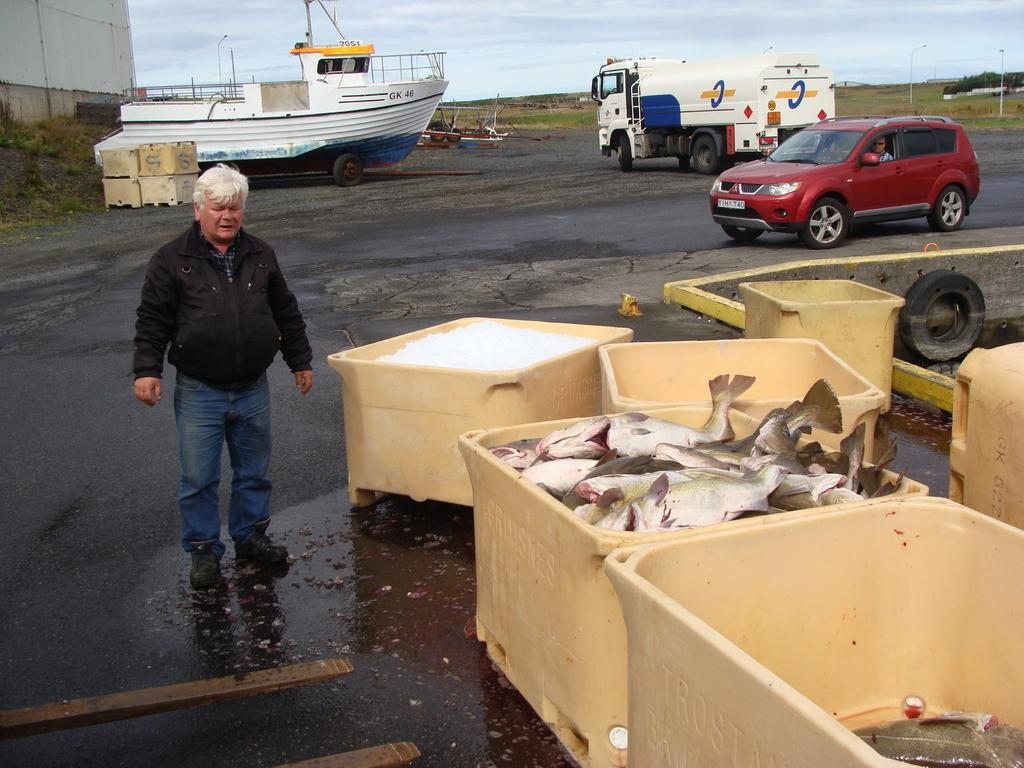What is the main subject of the image? There is a man standing in the image. What can be seen near the man? There is a box with fish in the image. What else is present in the image besides the man and the box with fish? There are vehicles present in the image. What type of lace is being used to hold the fish in the box? There is no lace present in the image; the fish are contained within a box. 